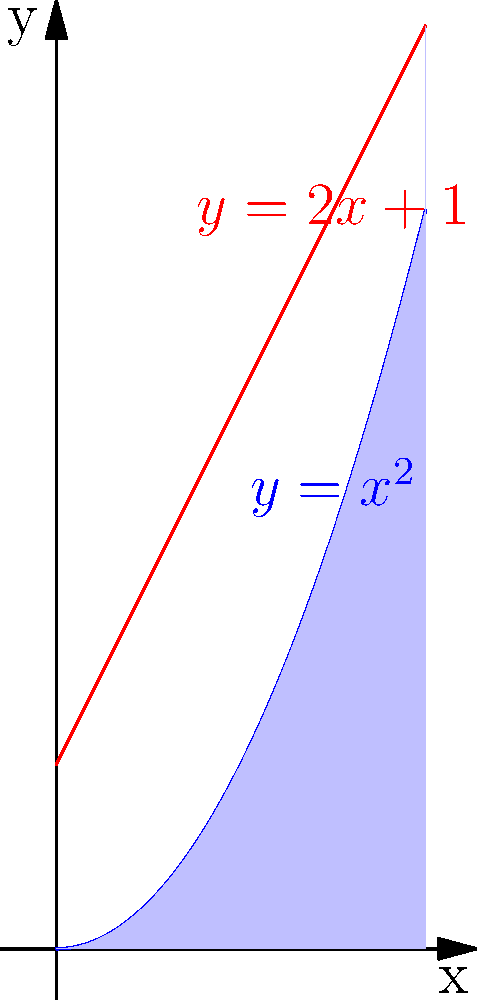Calculate the area of the region bounded by the parabola $y = x^2$ and the line $y = 2x + 1$. Round your answer to two decimal places. To find the area of the region bounded by the parabola and the line, we need to follow these steps:

1) First, find the points of intersection of the parabola and the line:
   $x^2 = 2x + 1$
   $x^2 - 2x - 1 = 0$
   $(x - 2)(x + 1) = 0$
   $x = 2$ or $x = -1$

   The region we're interested in is between $x = 0$ and $x = 2$.

2) The area is the difference between the integral of the line and the integral of the parabola from 0 to 2:

   $A = \int_0^2 (2x + 1) dx - \int_0^2 x^2 dx$

3) Integrate the line:
   $\int_0^2 (2x + 1) dx = [x^2 + x]_0^2 = (4 + 2) - (0 + 0) = 6$

4) Integrate the parabola:
   $\int_0^2 x^2 dx = [\frac{1}{3}x^3]_0^2 = \frac{8}{3} - 0 = \frac{8}{3}$

5) Calculate the difference:
   $A = 6 - \frac{8}{3} = 6 - \frac{8}{3} = \frac{18}{3} - \frac{8}{3} = \frac{10}{3} \approx 3.33$

Therefore, the area of the region is approximately 3.33 square units.
Answer: $3.33$ square units 